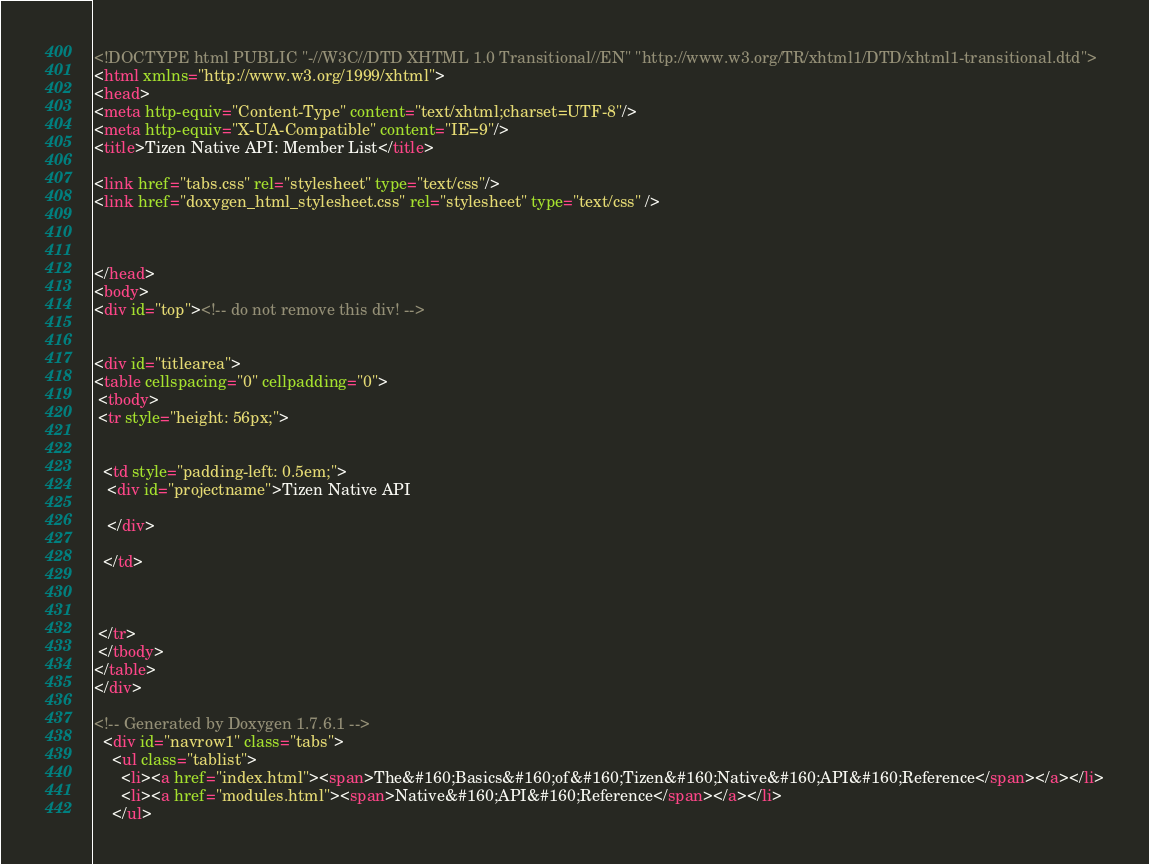<code> <loc_0><loc_0><loc_500><loc_500><_HTML_><!DOCTYPE html PUBLIC "-//W3C//DTD XHTML 1.0 Transitional//EN" "http://www.w3.org/TR/xhtml1/DTD/xhtml1-transitional.dtd">
<html xmlns="http://www.w3.org/1999/xhtml">
<head>
<meta http-equiv="Content-Type" content="text/xhtml;charset=UTF-8"/>
<meta http-equiv="X-UA-Compatible" content="IE=9"/>
<title>Tizen Native API: Member List</title>

<link href="tabs.css" rel="stylesheet" type="text/css"/>
<link href="doxygen_html_stylesheet.css" rel="stylesheet" type="text/css" />



</head>
<body>
<div id="top"><!-- do not remove this div! -->


<div id="titlearea">
<table cellspacing="0" cellpadding="0">
 <tbody>
 <tr style="height: 56px;">
  
  
  <td style="padding-left: 0.5em;">
   <div id="projectname">Tizen Native API
   
   </div>
   
  </td>
  
  
  
 </tr>
 </tbody>
</table>
</div>

<!-- Generated by Doxygen 1.7.6.1 -->
  <div id="navrow1" class="tabs">
    <ul class="tablist">
      <li><a href="index.html"><span>The&#160;Basics&#160;of&#160;Tizen&#160;Native&#160;API&#160;Reference</span></a></li>
      <li><a href="modules.html"><span>Native&#160;API&#160;Reference</span></a></li>
    </ul></code> 